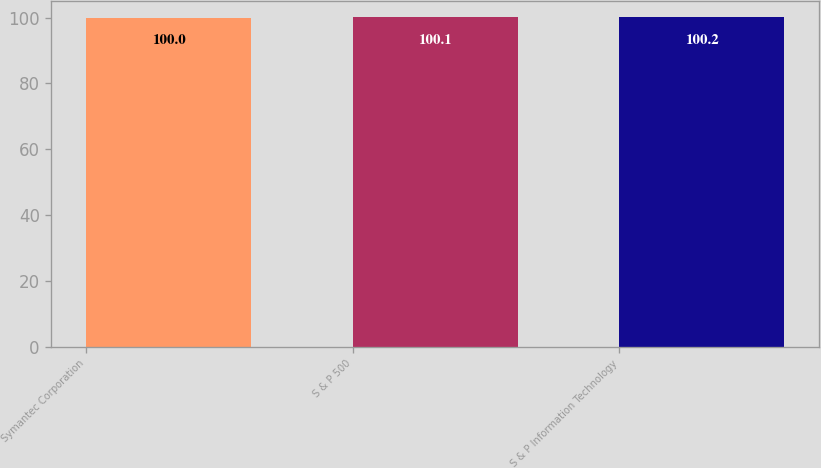Convert chart. <chart><loc_0><loc_0><loc_500><loc_500><bar_chart><fcel>Symantec Corporation<fcel>S & P 500<fcel>S & P Information Technology<nl><fcel>100<fcel>100.1<fcel>100.2<nl></chart> 